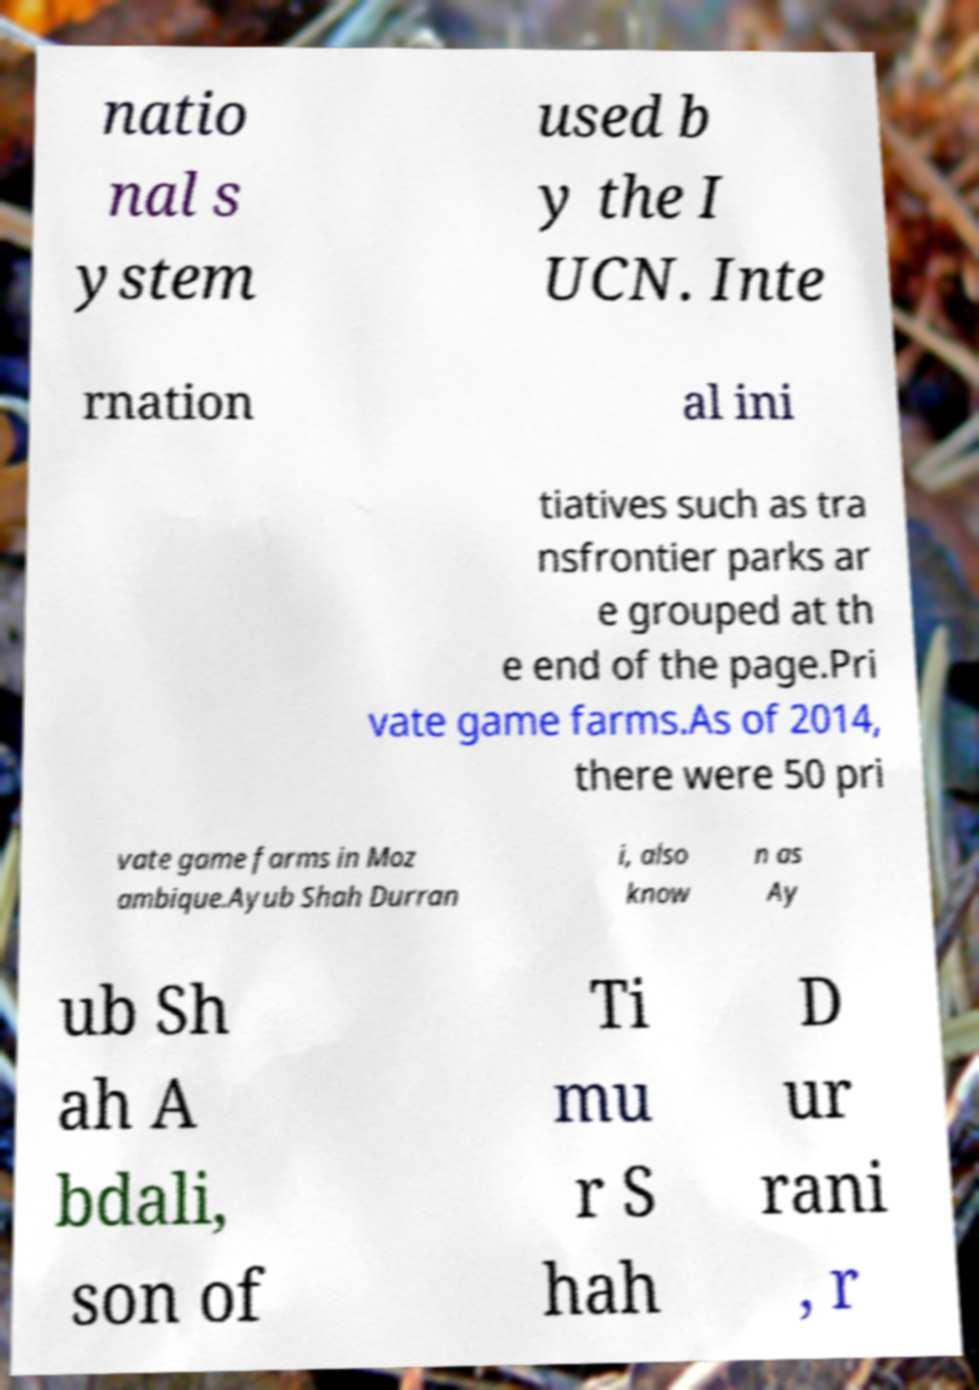For documentation purposes, I need the text within this image transcribed. Could you provide that? natio nal s ystem used b y the I UCN. Inte rnation al ini tiatives such as tra nsfrontier parks ar e grouped at th e end of the page.Pri vate game farms.As of 2014, there were 50 pri vate game farms in Moz ambique.Ayub Shah Durran i, also know n as Ay ub Sh ah A bdali, son of Ti mu r S hah D ur rani , r 